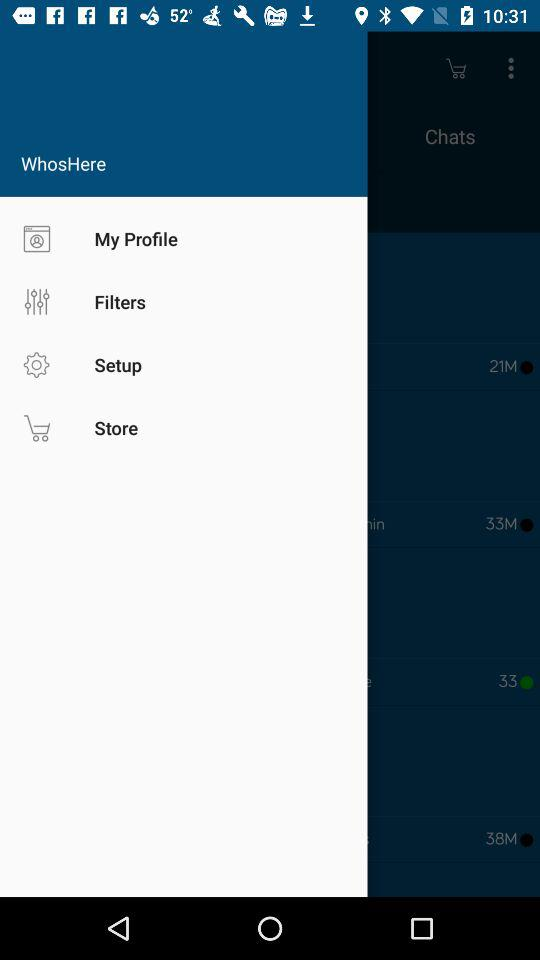How many more followers does the user with 38M have than the one with 21M?
Answer the question using a single word or phrase. 17M 